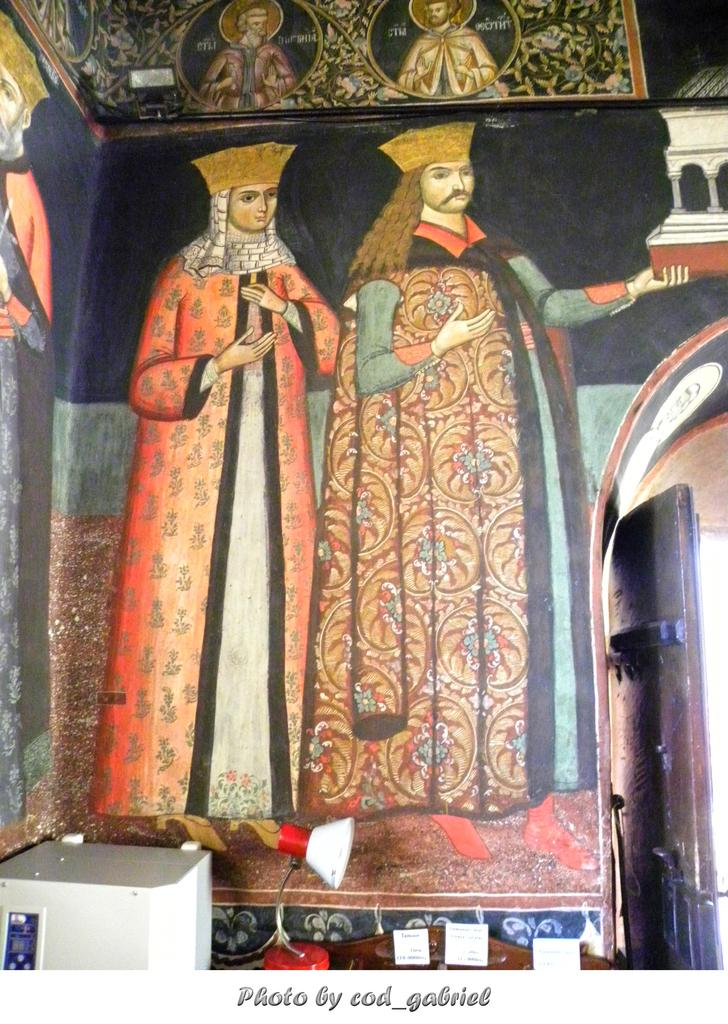What is present in the image? There is a wall in the image. What can be seen on the wall? There are two persons on the wall. Can you describe the clothing of the person on the right? The person on the right is wearing a brown dress. How about the person on the left? The person on the left is wearing an orange and cream color dress. What type of clouds can be seen in the aftermath of the event depicted in the image? There are no clouds or events depicted in the image; it only features a wall with two persons on it. Can you spot any ducks in the image? There are no ducks present in the image. 